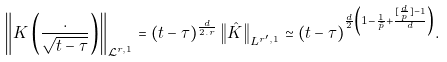<formula> <loc_0><loc_0><loc_500><loc_500>\left \| K \left ( \frac { . } { \sqrt { t - \tau } } \right ) \right \| _ { \mathcal { L } ^ { r , 1 } } = ( t - \tau ) ^ { \frac { d } { 2 . r } } \left \| \hat { K } \right \| _ { L ^ { r ^ { \prime } , 1 } } \simeq ( t - \tau ) ^ { \frac { d } { 2 } \left ( 1 - \frac { 1 } { \tilde { p } } + \frac { [ \frac { d } { p } ] - 1 } { d } \right ) } .</formula> 